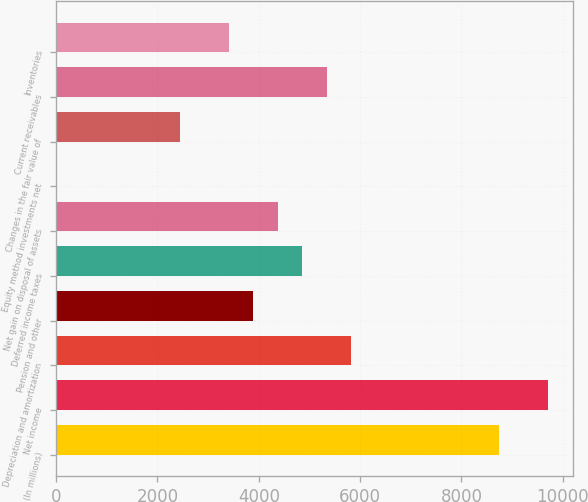Convert chart. <chart><loc_0><loc_0><loc_500><loc_500><bar_chart><fcel>(In millions)<fcel>Net income<fcel>Depreciation and amortization<fcel>Pension and other<fcel>Deferred income taxes<fcel>Net gain on disposal of assets<fcel>Equity method investments net<fcel>Changes in the fair value of<fcel>Current receivables<fcel>Inventories<nl><fcel>8739.2<fcel>9709<fcel>5829.8<fcel>3890.2<fcel>4860<fcel>4375.1<fcel>11<fcel>2435.5<fcel>5344.9<fcel>3405.3<nl></chart> 